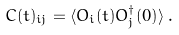Convert formula to latex. <formula><loc_0><loc_0><loc_500><loc_500>C ( t ) _ { i j } = \langle O _ { i } ( t ) O _ { j } ^ { \dagger } ( 0 ) \rangle \, .</formula> 